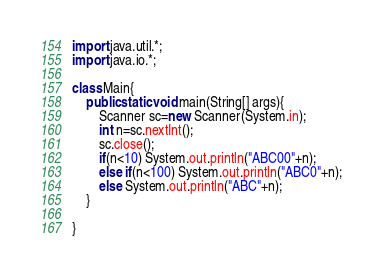<code> <loc_0><loc_0><loc_500><loc_500><_Java_>import java.util.*;
import java.io.*;

class Main{
    public static void main(String[] args){
        Scanner sc=new Scanner(System.in);
        int n=sc.nextInt();
        sc.close();
        if(n<10) System.out.println("ABC00"+n);
        else if(n<100) System.out.println("ABC0"+n);
        else System.out.println("ABC"+n);
    }
    
}
</code> 